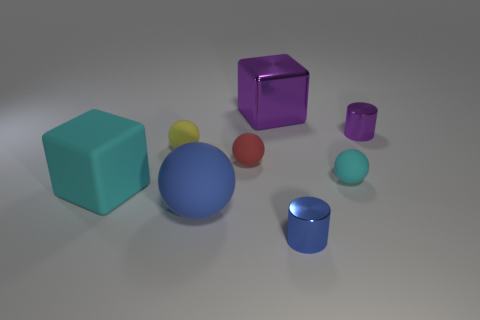What color is the big object that is made of the same material as the large blue ball?
Offer a terse response. Cyan. Are there any other purple cubes of the same size as the purple cube?
Offer a terse response. No. Are there more shiny things that are right of the large purple block than small rubber objects on the right side of the red matte object?
Make the answer very short. Yes. Do the small cylinder behind the big cyan rubber block and the sphere right of the small blue thing have the same material?
Your response must be concise. No. There is a purple object that is the same size as the cyan rubber sphere; what shape is it?
Offer a very short reply. Cylinder. Are there any small gray things of the same shape as the small cyan matte thing?
Keep it short and to the point. No. There is a small metal cylinder that is right of the tiny blue thing; is its color the same as the large block to the right of the red rubber thing?
Make the answer very short. Yes. Are there any large purple objects on the left side of the rubber block?
Keep it short and to the point. No. What material is the object that is to the right of the blue metallic object and behind the red rubber ball?
Your response must be concise. Metal. Is the cube that is to the left of the large blue rubber thing made of the same material as the small red thing?
Offer a very short reply. Yes. 